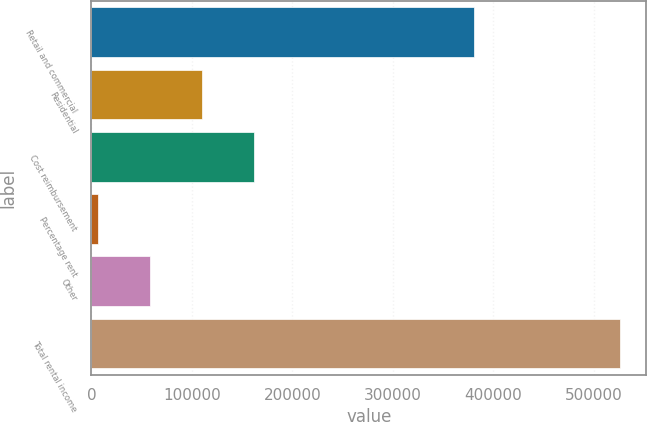<chart> <loc_0><loc_0><loc_500><loc_500><bar_chart><fcel>Retail and commercial<fcel>Residential<fcel>Cost reimbursement<fcel>Percentage rent<fcel>Other<fcel>Total rental income<nl><fcel>381012<fcel>110205<fcel>162120<fcel>6374<fcel>58289.4<fcel>525528<nl></chart> 